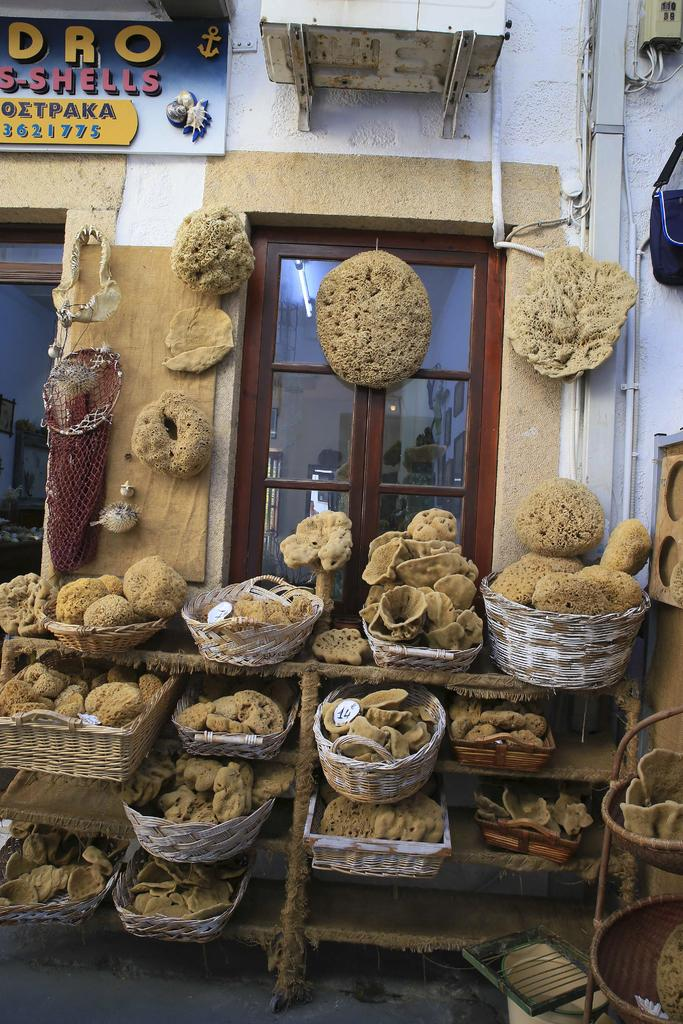What is inside the baskets in the image? There are objects in the baskets. What can be seen beneath the baskets in the image? The floor is visible in the image. What architectural features are visible in the background of the image? There is a door, a wall, and a board in the background of the image. What type of loaf is being prepared by the manager in the image? There is no manager or loaf present in the image. 